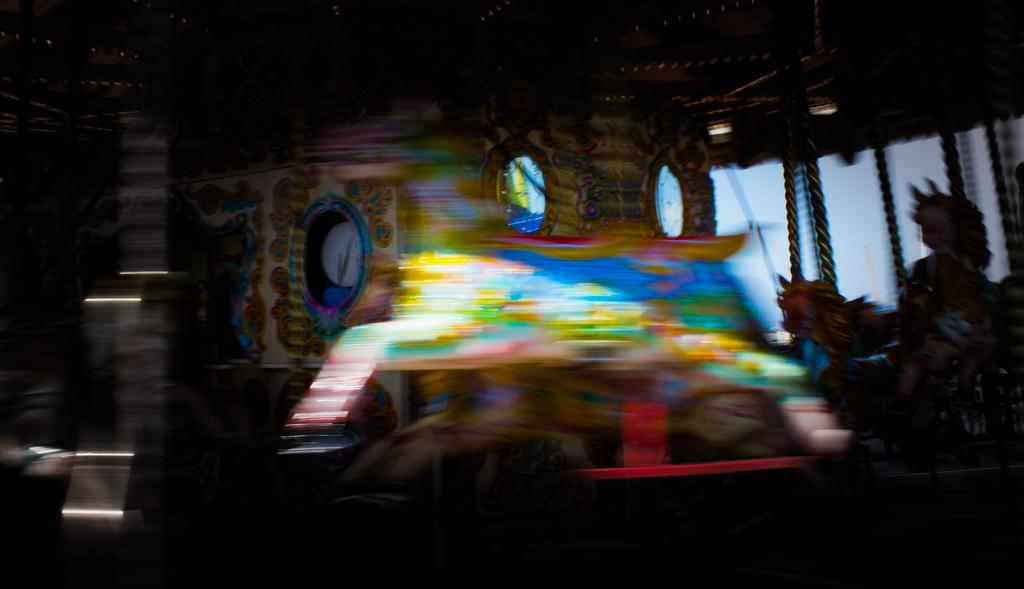Can you describe the overall appearance of the image? The image is blurred. How many straws are visible in the image? There are no straws present in the image, as it is blurred and no specific objects can be identified. 